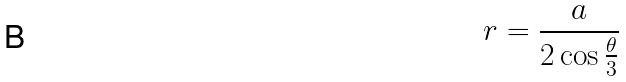Convert formula to latex. <formula><loc_0><loc_0><loc_500><loc_500>r = \frac { a } { 2 \cos \frac { \theta } { 3 } }</formula> 